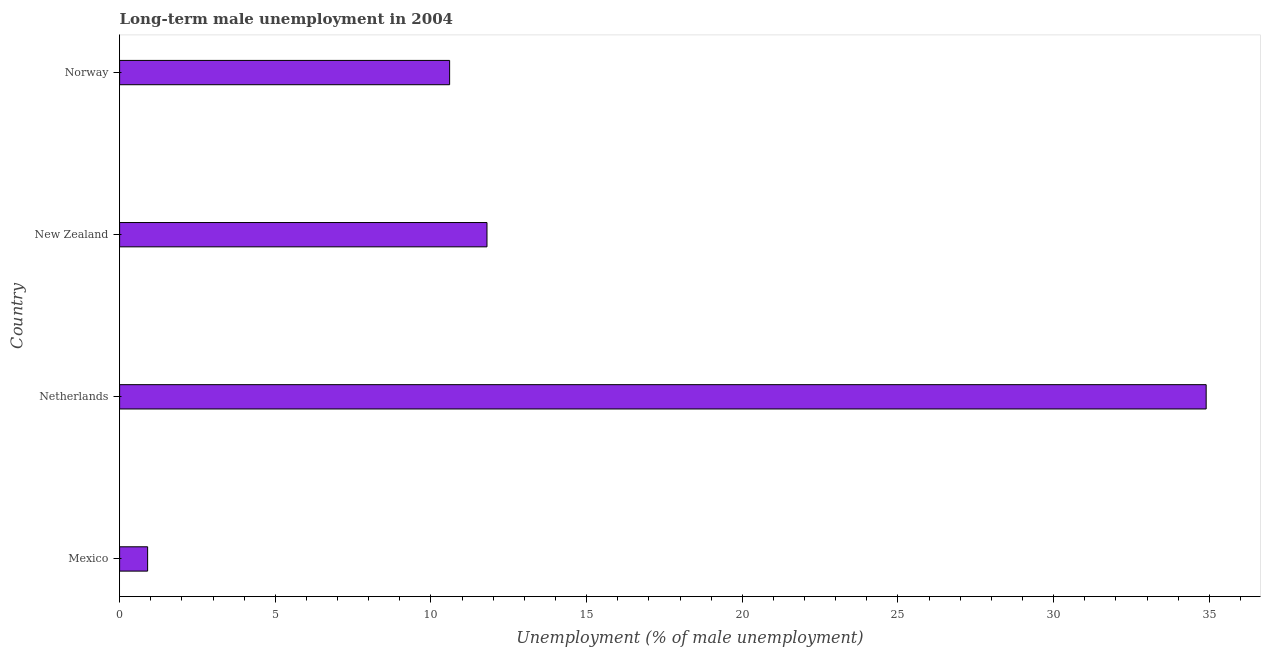Does the graph contain grids?
Your answer should be very brief. No. What is the title of the graph?
Your response must be concise. Long-term male unemployment in 2004. What is the label or title of the X-axis?
Keep it short and to the point. Unemployment (% of male unemployment). What is the long-term male unemployment in New Zealand?
Provide a succinct answer. 11.8. Across all countries, what is the maximum long-term male unemployment?
Give a very brief answer. 34.9. Across all countries, what is the minimum long-term male unemployment?
Give a very brief answer. 0.9. In which country was the long-term male unemployment maximum?
Your answer should be compact. Netherlands. What is the sum of the long-term male unemployment?
Keep it short and to the point. 58.2. What is the difference between the long-term male unemployment in Netherlands and New Zealand?
Keep it short and to the point. 23.1. What is the average long-term male unemployment per country?
Give a very brief answer. 14.55. What is the median long-term male unemployment?
Give a very brief answer. 11.2. What is the ratio of the long-term male unemployment in Mexico to that in Netherlands?
Offer a very short reply. 0.03. Is the difference between the long-term male unemployment in Mexico and New Zealand greater than the difference between any two countries?
Offer a terse response. No. What is the difference between the highest and the second highest long-term male unemployment?
Provide a succinct answer. 23.1. How many bars are there?
Make the answer very short. 4. Are all the bars in the graph horizontal?
Your response must be concise. Yes. What is the Unemployment (% of male unemployment) in Mexico?
Ensure brevity in your answer.  0.9. What is the Unemployment (% of male unemployment) in Netherlands?
Offer a very short reply. 34.9. What is the Unemployment (% of male unemployment) of New Zealand?
Ensure brevity in your answer.  11.8. What is the Unemployment (% of male unemployment) in Norway?
Make the answer very short. 10.6. What is the difference between the Unemployment (% of male unemployment) in Mexico and Netherlands?
Your response must be concise. -34. What is the difference between the Unemployment (% of male unemployment) in Mexico and New Zealand?
Provide a short and direct response. -10.9. What is the difference between the Unemployment (% of male unemployment) in Mexico and Norway?
Your response must be concise. -9.7. What is the difference between the Unemployment (% of male unemployment) in Netherlands and New Zealand?
Keep it short and to the point. 23.1. What is the difference between the Unemployment (% of male unemployment) in Netherlands and Norway?
Your response must be concise. 24.3. What is the difference between the Unemployment (% of male unemployment) in New Zealand and Norway?
Keep it short and to the point. 1.2. What is the ratio of the Unemployment (% of male unemployment) in Mexico to that in Netherlands?
Keep it short and to the point. 0.03. What is the ratio of the Unemployment (% of male unemployment) in Mexico to that in New Zealand?
Provide a short and direct response. 0.08. What is the ratio of the Unemployment (% of male unemployment) in Mexico to that in Norway?
Your answer should be compact. 0.09. What is the ratio of the Unemployment (% of male unemployment) in Netherlands to that in New Zealand?
Offer a very short reply. 2.96. What is the ratio of the Unemployment (% of male unemployment) in Netherlands to that in Norway?
Your answer should be very brief. 3.29. What is the ratio of the Unemployment (% of male unemployment) in New Zealand to that in Norway?
Provide a succinct answer. 1.11. 